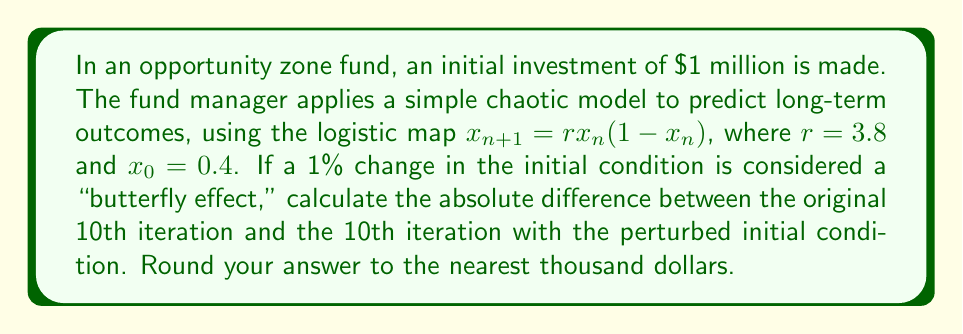Can you solve this math problem? 1. Set up the original logistic map:
   $x_{n+1} = 3.8x_n(1-x_n)$, $x_0 = 0.4$

2. Calculate the first 10 iterations:
   $x_1 = 3.8 * 0.4 * (1-0.4) = 0.912$
   $x_2 = 3.8 * 0.912 * (1-0.912) = 0.305472$
   $x_3 = 3.8 * 0.305472 * (1-0.305472) = 0.805716$
   ...
   $x_{10} = 0.525690$

3. Set up the perturbed logistic map:
   $y_{n+1} = 3.8y_n(1-y_n)$, $y_0 = 0.404$ (1% increase)

4. Calculate the first 10 iterations of the perturbed map:
   $y_1 = 3.8 * 0.404 * (1-0.404) = 0.915091$
   $y_2 = 3.8 * 0.915091 * (1-0.915091) = 0.296272$
   $y_3 = 3.8 * 0.296272 * (1-0.296272) = 0.792241$
   ...
   $y_{10} = 0.884751$

5. Calculate the absolute difference:
   $|x_{10} - y_{10}| = |0.525690 - 0.884751| = 0.359061$

6. Convert to dollar amount:
   $0.359061 * $1,000,000 = $359,061$

7. Round to the nearest thousand:
   $359,061 ≈ $359,000$
Answer: $359,000 